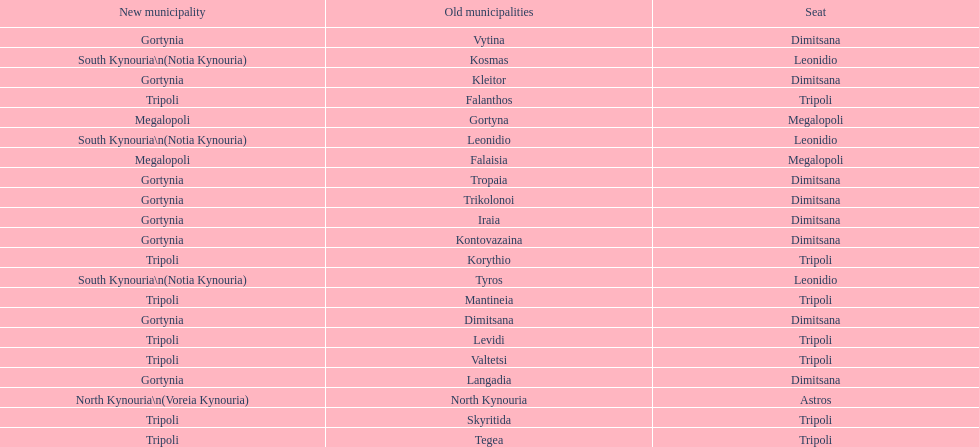What is the new municipality of tyros? South Kynouria. 